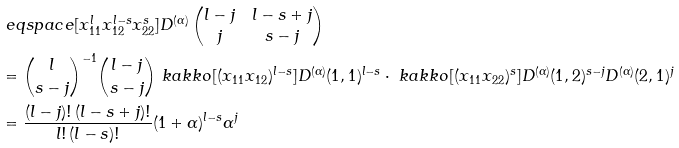<formula> <loc_0><loc_0><loc_500><loc_500>& \ e q s p a c e [ x _ { 1 1 } ^ { l } x _ { 1 2 } ^ { l - s } x _ { 2 2 } ^ { s } ] D ^ { ( \alpha ) } \begin{pmatrix} l - j & l - s + j \\ j & s - j \end{pmatrix} \\ & = \binom { l } { s - j } ^ { - 1 } \binom { l - j } { s - j } \ k a k k o { [ ( x _ { 1 1 } x _ { 1 2 } ) ^ { l - s } ] D ^ { ( \alpha ) } ( 1 , 1 ) ^ { l - s } } \cdot \ k a k k o { [ ( x _ { 1 1 } x _ { 2 2 } ) ^ { s } ] D ^ { ( \alpha ) } ( 1 , 2 ) ^ { s - j } D ^ { ( \alpha ) } ( 2 , 1 ) ^ { j } } \\ & = \frac { ( l - j ) ! \, ( l - s + j ) ! } { l ! \, ( l - s ) ! } ( 1 + \alpha ) ^ { l - s } \alpha ^ { j }</formula> 